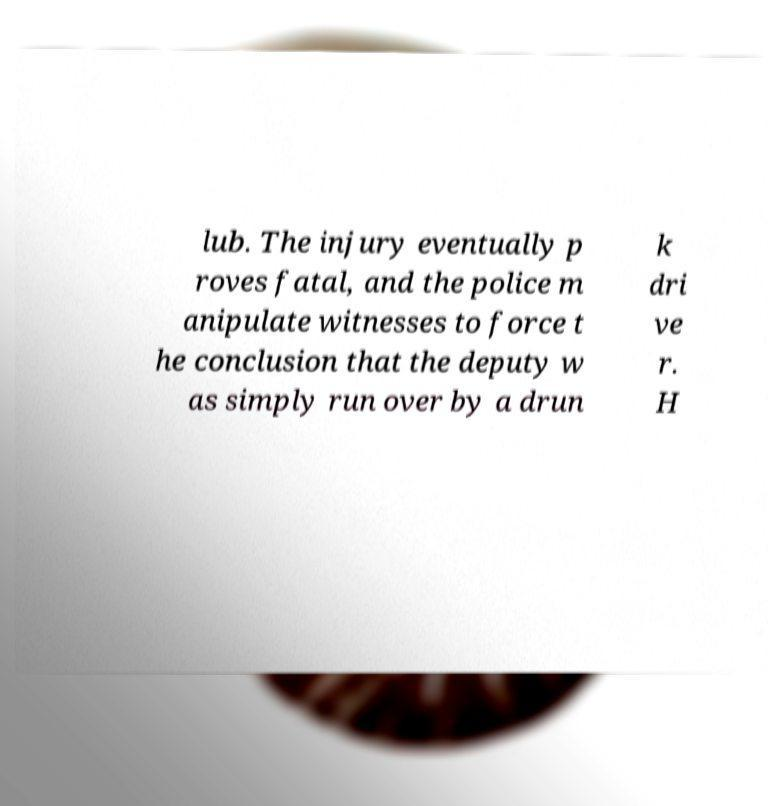Can you read and provide the text displayed in the image?This photo seems to have some interesting text. Can you extract and type it out for me? lub. The injury eventually p roves fatal, and the police m anipulate witnesses to force t he conclusion that the deputy w as simply run over by a drun k dri ve r. H 